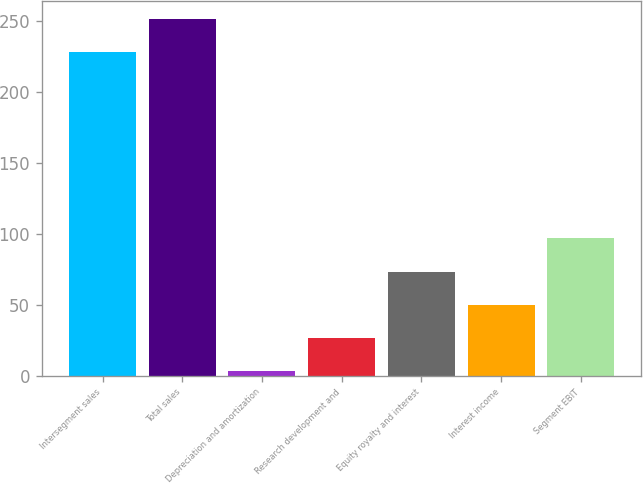Convert chart. <chart><loc_0><loc_0><loc_500><loc_500><bar_chart><fcel>Intersegment sales<fcel>Total sales<fcel>Depreciation and amortization<fcel>Research development and<fcel>Equity royalty and interest<fcel>Interest income<fcel>Segment EBIT<nl><fcel>228<fcel>251.4<fcel>3<fcel>26.4<fcel>73.2<fcel>49.8<fcel>96.6<nl></chart> 